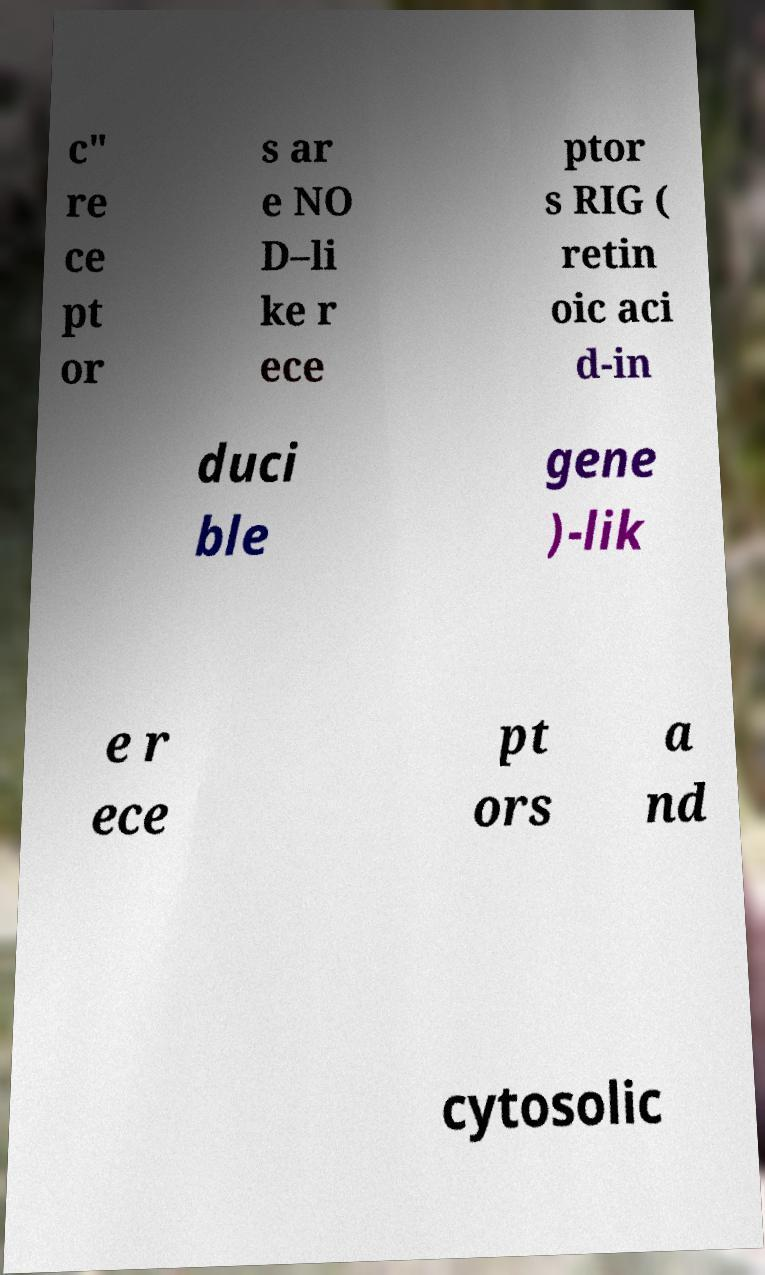Can you accurately transcribe the text from the provided image for me? c" re ce pt or s ar e NO D–li ke r ece ptor s RIG ( retin oic aci d-in duci ble gene )-lik e r ece pt ors a nd cytosolic 